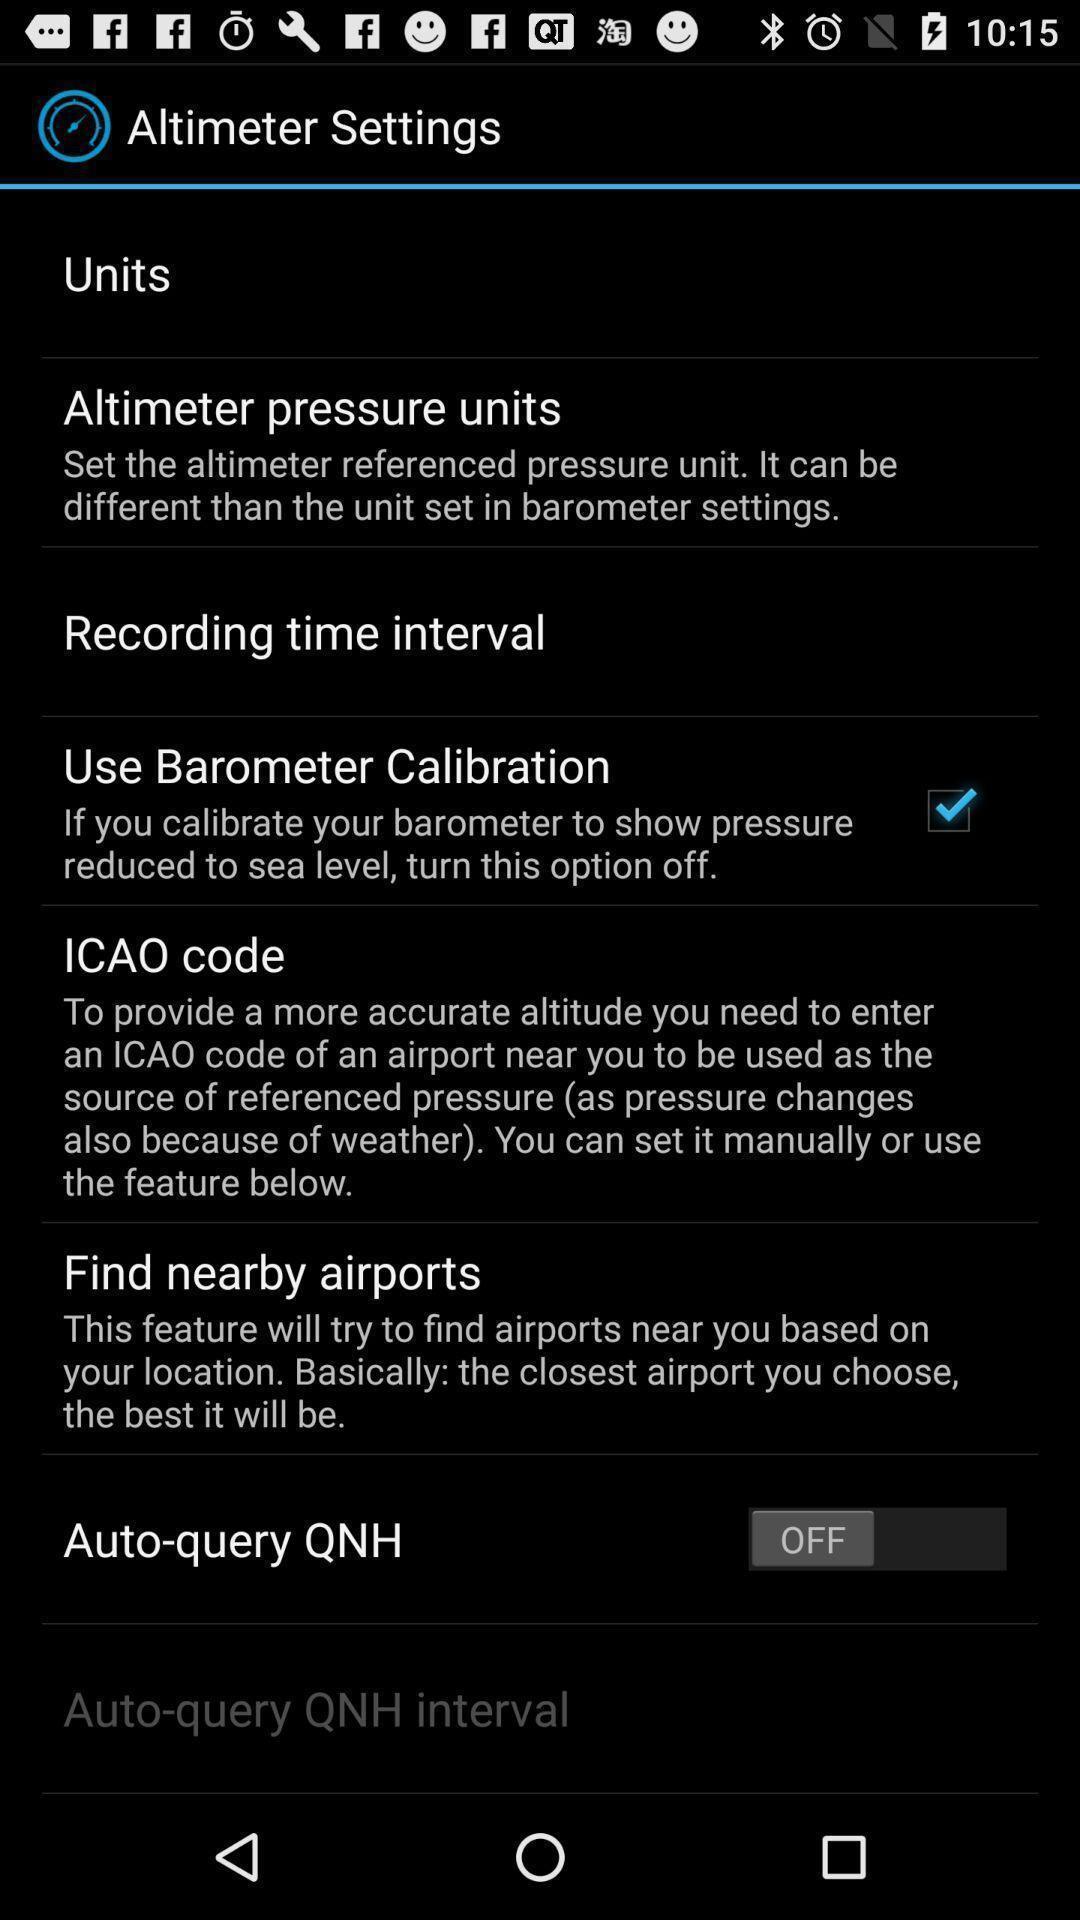What can you discern from this picture? Settings page in a altimeter app. 